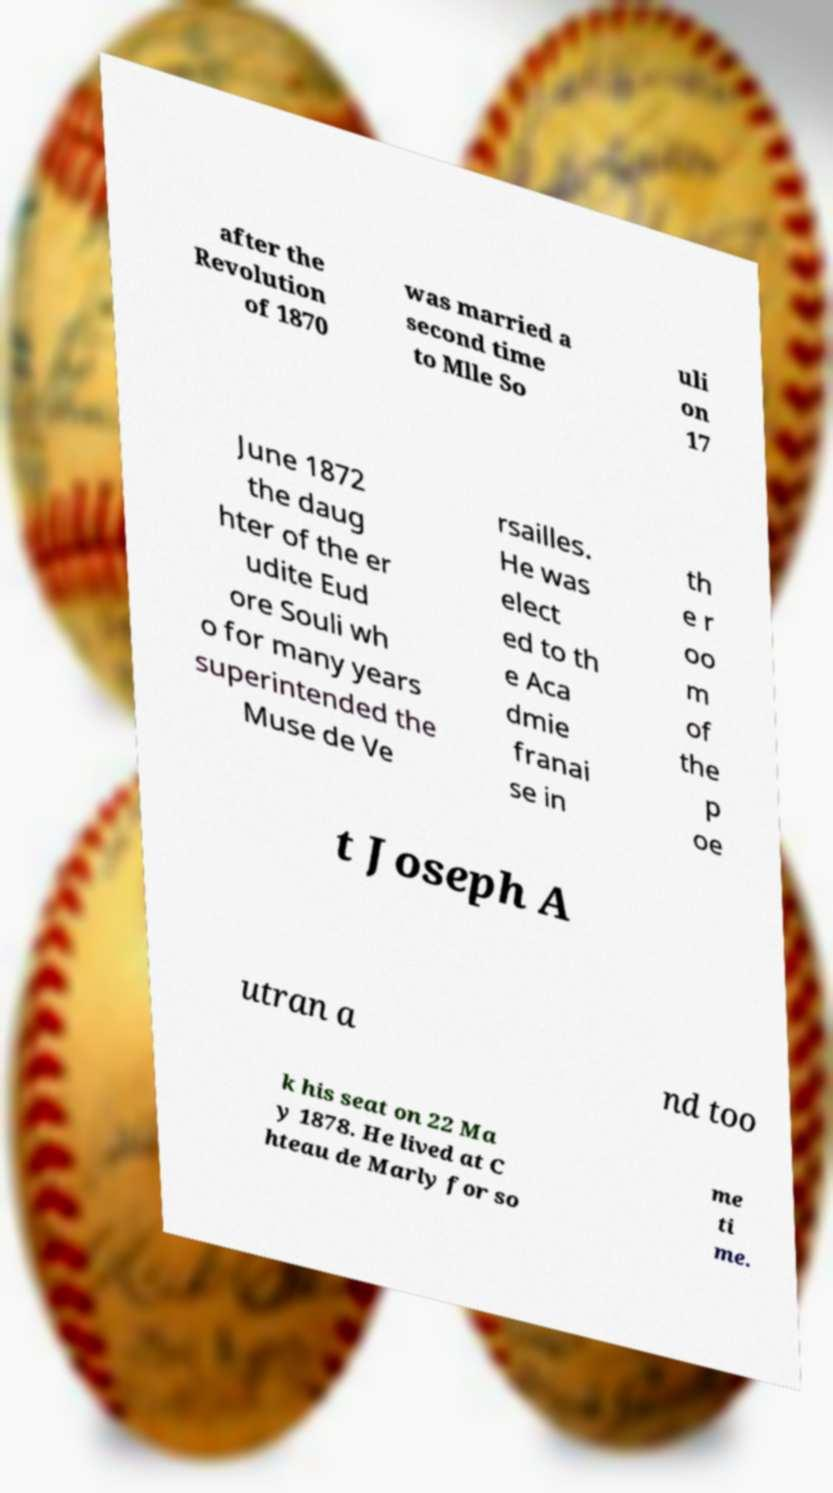Could you assist in decoding the text presented in this image and type it out clearly? after the Revolution of 1870 was married a second time to Mlle So uli on 17 June 1872 the daug hter of the er udite Eud ore Souli wh o for many years superintended the Muse de Ve rsailles. He was elect ed to th e Aca dmie franai se in th e r oo m of the p oe t Joseph A utran a nd too k his seat on 22 Ma y 1878. He lived at C hteau de Marly for so me ti me. 